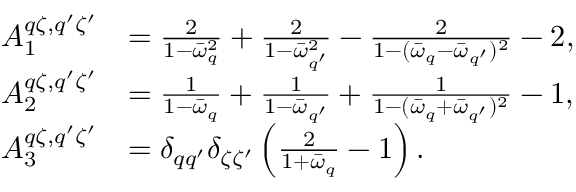<formula> <loc_0><loc_0><loc_500><loc_500>\begin{array} { r l } { A _ { 1 } ^ { q \zeta , q ^ { \prime } \zeta ^ { \prime } } } & { = \frac { 2 } { 1 - \bar { \omega } _ { q } ^ { 2 } } + \frac { 2 } { 1 - \bar { \omega } _ { q ^ { \prime } } ^ { 2 } } - \frac { 2 } { 1 - ( \bar { \omega } _ { q } - \bar { \omega } _ { q ^ { \prime } } ) ^ { 2 } } - 2 , } \\ { A _ { 2 } ^ { q \zeta , q ^ { \prime } \zeta ^ { \prime } } } & { = \frac { 1 } { 1 - \bar { \omega } _ { q } } + \frac { 1 } { 1 - \bar { \omega } _ { q ^ { \prime } } } + \frac { 1 } { 1 - ( \bar { \omega } _ { q } + \bar { \omega } _ { q ^ { \prime } } ) ^ { 2 } } - 1 , } \\ { A _ { 3 } ^ { q \zeta , q ^ { \prime } \zeta ^ { \prime } } } & { = \delta _ { q q ^ { \prime } } \delta _ { \zeta \zeta ^ { \prime } } \left ( \frac { 2 } { 1 + \bar { \omega } _ { q } } - 1 \right ) . } \end{array}</formula> 